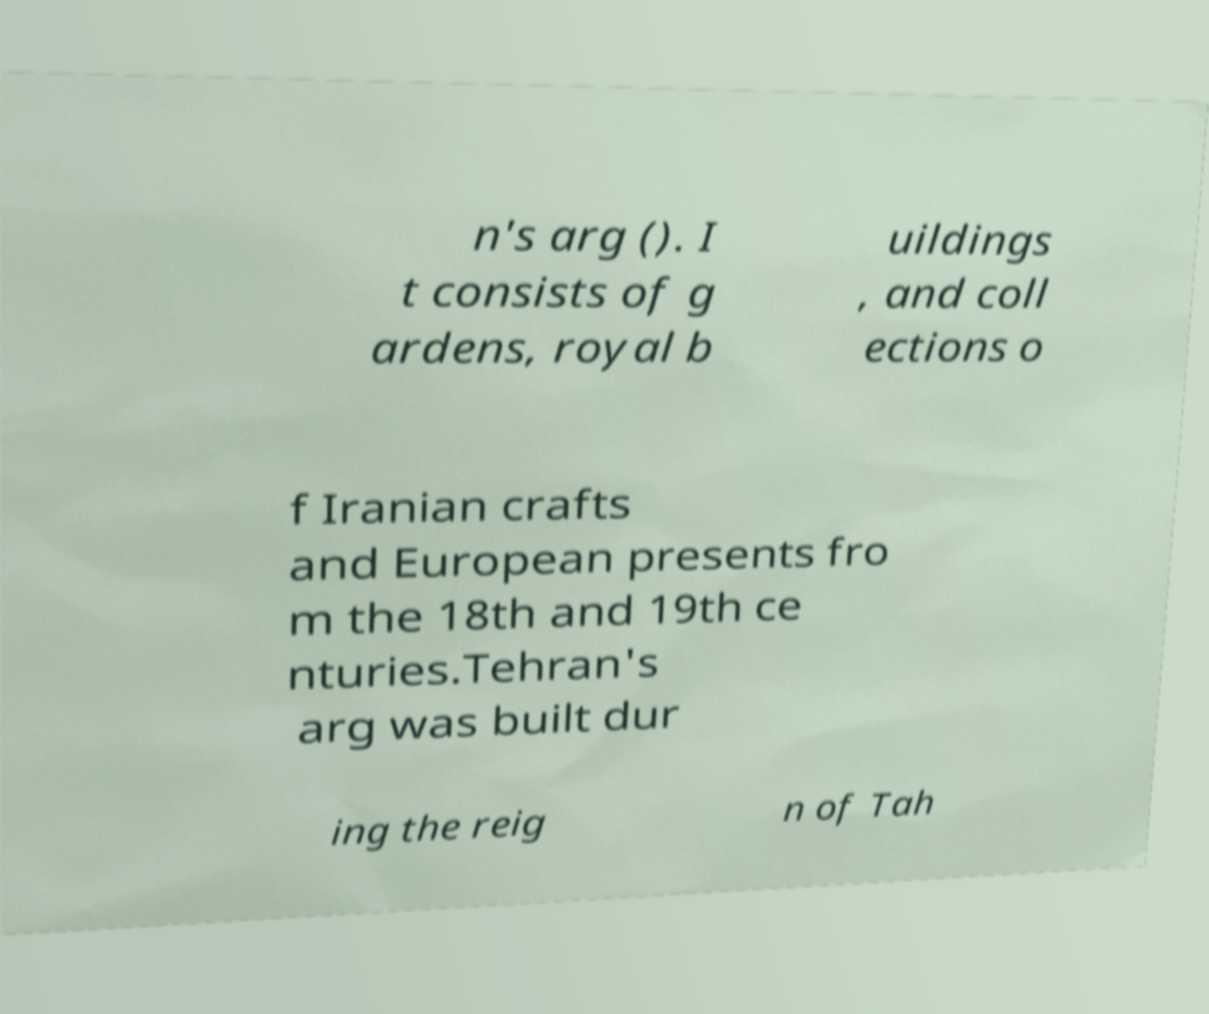I need the written content from this picture converted into text. Can you do that? n's arg (). I t consists of g ardens, royal b uildings , and coll ections o f Iranian crafts and European presents fro m the 18th and 19th ce nturies.Tehran's arg was built dur ing the reig n of Tah 